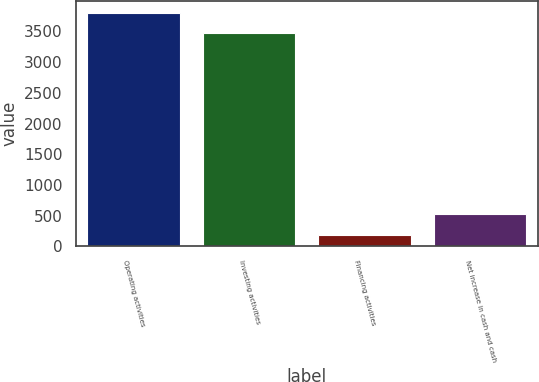Convert chart to OTSL. <chart><loc_0><loc_0><loc_500><loc_500><bar_chart><fcel>Operating activities<fcel>Investing activities<fcel>Financing activities<fcel>Net increase in cash and cash<nl><fcel>3805.6<fcel>3474<fcel>191<fcel>522.6<nl></chart> 